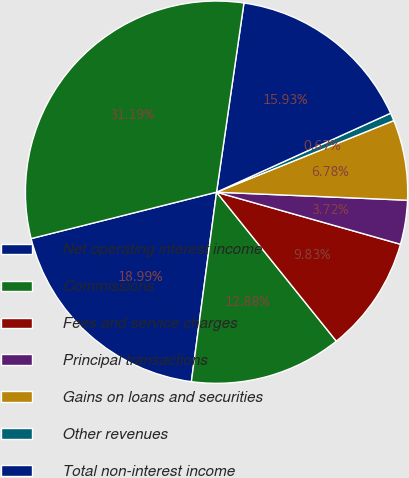<chart> <loc_0><loc_0><loc_500><loc_500><pie_chart><fcel>Net operating interest income<fcel>Commissions<fcel>Fees and service charges<fcel>Principal transactions<fcel>Gains on loans and securities<fcel>Other revenues<fcel>Total non-interest income<fcel>Total net revenue<nl><fcel>18.99%<fcel>12.88%<fcel>9.83%<fcel>3.72%<fcel>6.78%<fcel>0.67%<fcel>15.93%<fcel>31.19%<nl></chart> 